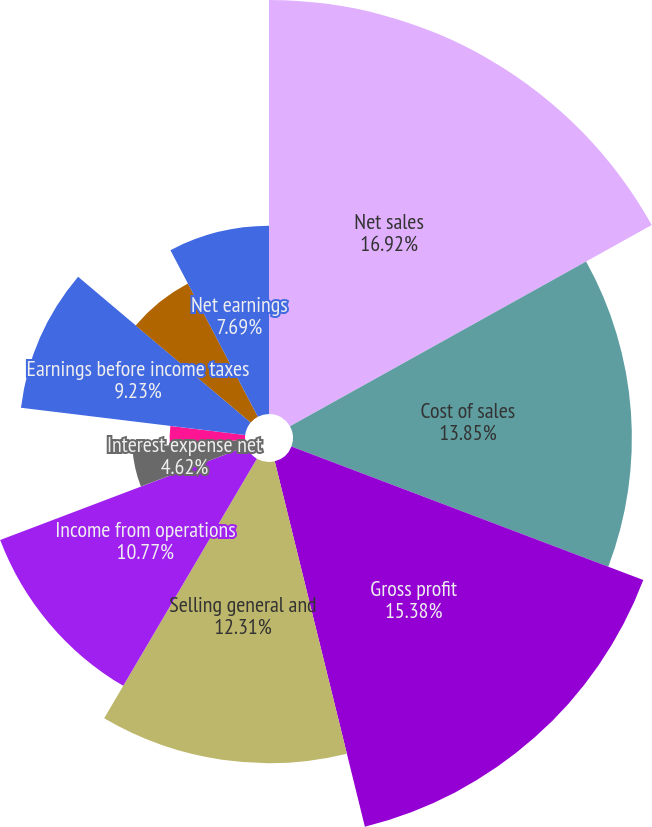Convert chart to OTSL. <chart><loc_0><loc_0><loc_500><loc_500><pie_chart><fcel>Net sales<fcel>Cost of sales<fcel>Gross profit<fcel>Selling general and<fcel>Income from operations<fcel>Interest expense net<fcel>Other income/(expense) net<fcel>Earnings before income taxes<fcel>Income taxes<fcel>Net earnings<nl><fcel>16.92%<fcel>13.85%<fcel>15.38%<fcel>12.31%<fcel>10.77%<fcel>4.62%<fcel>3.08%<fcel>9.23%<fcel>6.15%<fcel>7.69%<nl></chart> 